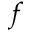Convert formula to latex. <formula><loc_0><loc_0><loc_500><loc_500>f</formula> 